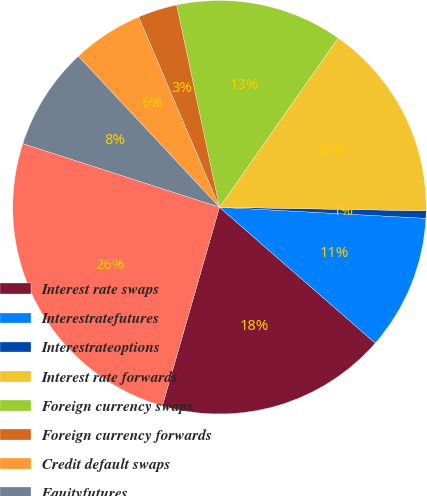<chart> <loc_0><loc_0><loc_500><loc_500><pie_chart><fcel>Interest rate swaps<fcel>Interestratefutures<fcel>Interestrateoptions<fcel>Interest rate forwards<fcel>Foreign currency swaps<fcel>Foreign currency forwards<fcel>Credit default swaps<fcel>Equityfutures<fcel>Total non-designated or<nl><fcel>18.04%<fcel>10.56%<fcel>0.58%<fcel>15.55%<fcel>13.05%<fcel>3.07%<fcel>5.57%<fcel>8.06%<fcel>25.52%<nl></chart> 